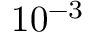<formula> <loc_0><loc_0><loc_500><loc_500>1 0 ^ { - 3 }</formula> 